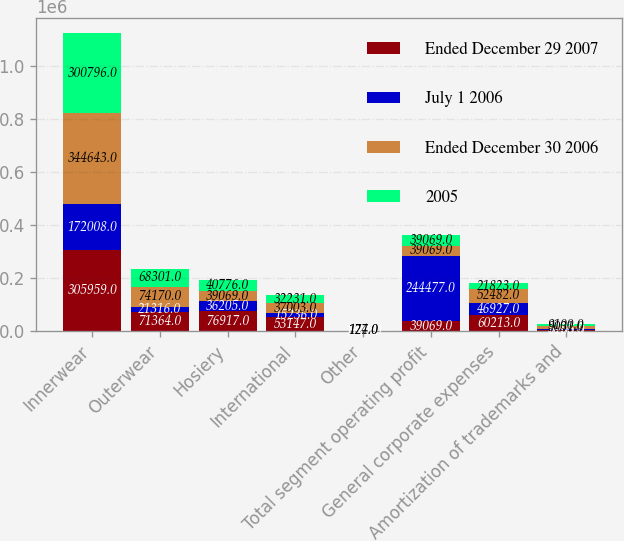Convert chart. <chart><loc_0><loc_0><loc_500><loc_500><stacked_bar_chart><ecel><fcel>Innerwear<fcel>Outerwear<fcel>Hosiery<fcel>International<fcel>Other<fcel>Total segment operating profit<fcel>General corporate expenses<fcel>Amortization of trademarks and<nl><fcel>Ended December 29 2007<fcel>305959<fcel>71364<fcel>76917<fcel>53147<fcel>1361<fcel>39069<fcel>60213<fcel>6205<nl><fcel>July 1 2006<fcel>172008<fcel>21316<fcel>36205<fcel>15236<fcel>288<fcel>244477<fcel>46927<fcel>3466<nl><fcel>Ended December 30 2006<fcel>344643<fcel>74170<fcel>39069<fcel>37003<fcel>127<fcel>39069<fcel>52482<fcel>9031<nl><fcel>2005<fcel>300796<fcel>68301<fcel>40776<fcel>32231<fcel>174<fcel>39069<fcel>21823<fcel>9100<nl></chart> 